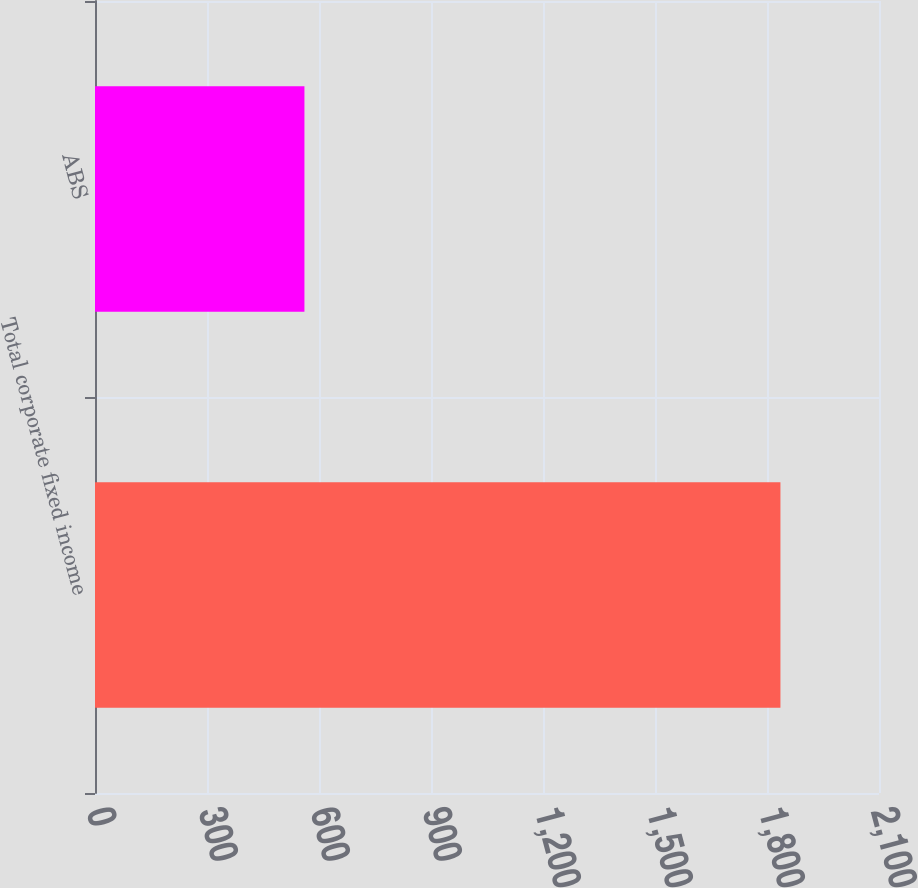Convert chart to OTSL. <chart><loc_0><loc_0><loc_500><loc_500><bar_chart><fcel>Total corporate fixed income<fcel>ABS<nl><fcel>1836<fcel>561<nl></chart> 